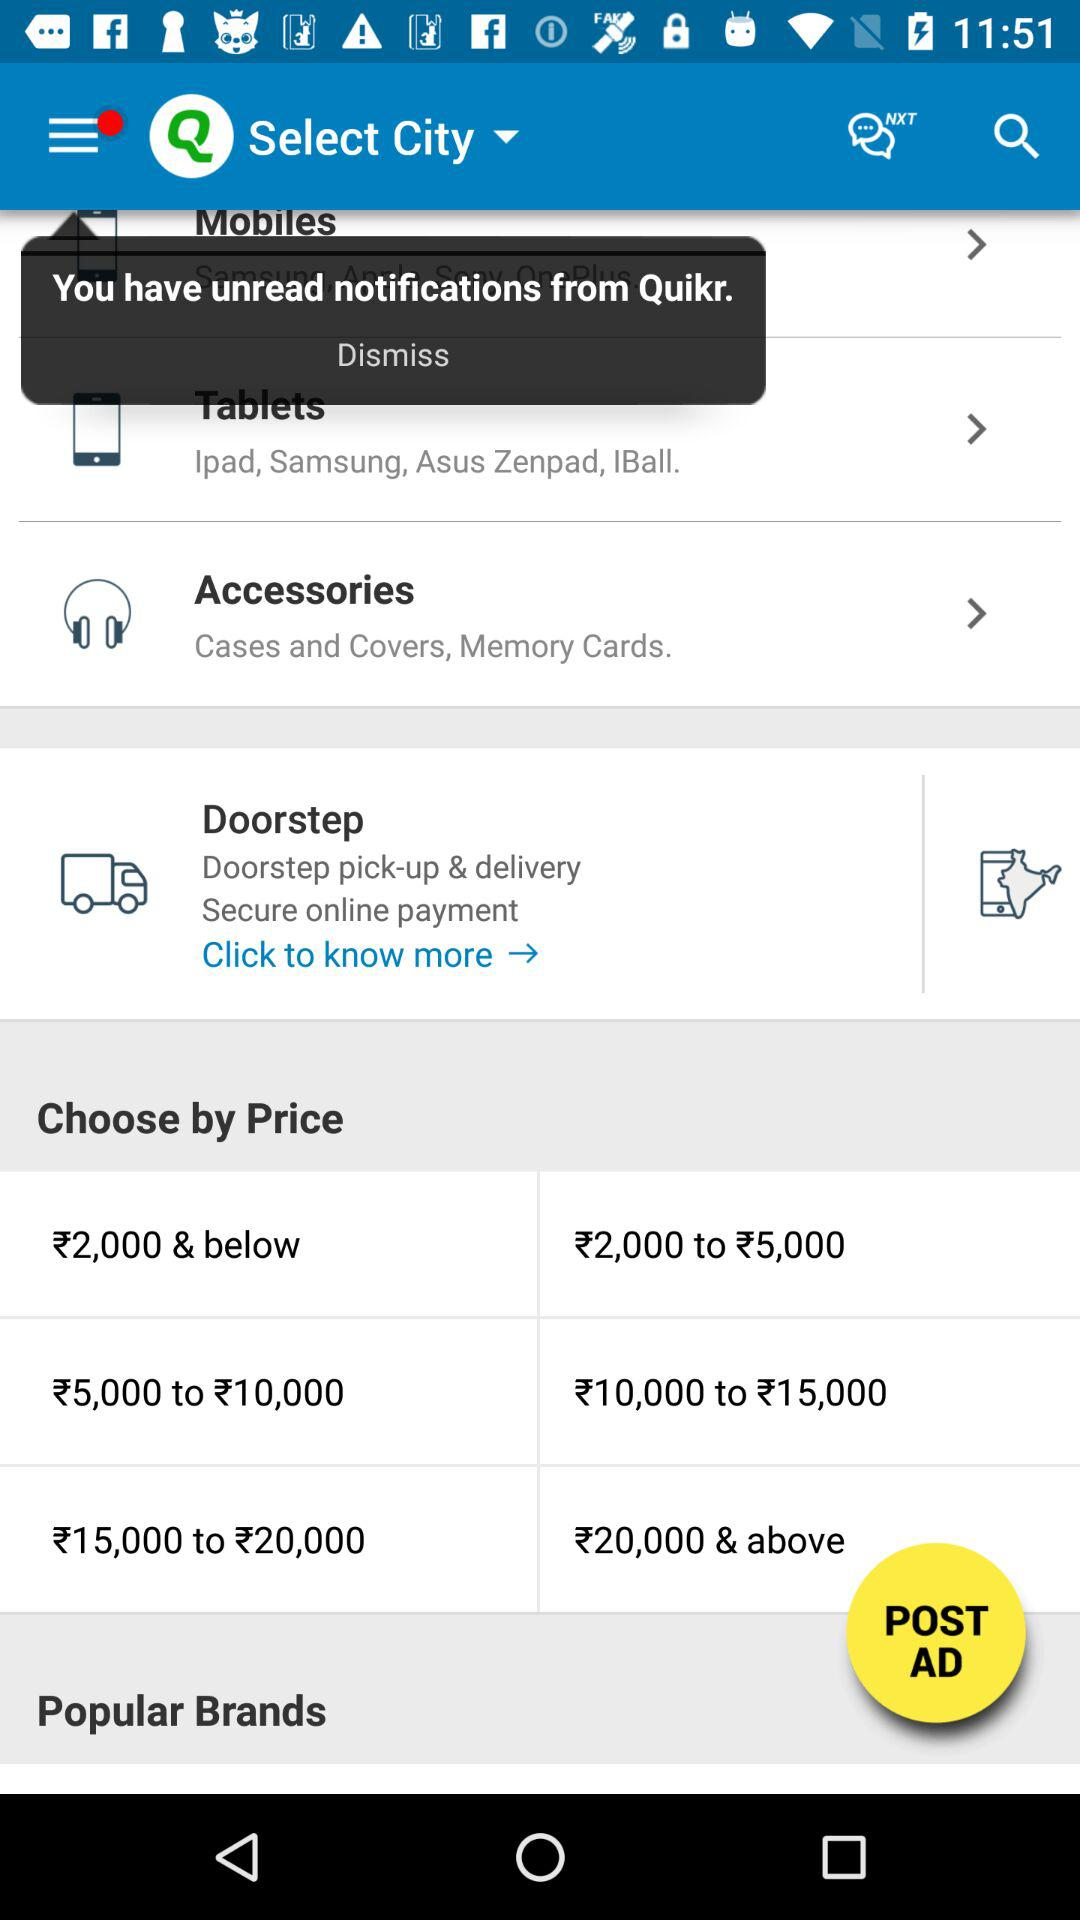What are the price ranges? The price ranges are ₹2,000 & below, ₹2,000 to ₹5,000, ₹5,000 to ₹10,000, ₹10,000 to ₹15,000, ₹15,000 to ₹20,000 and ₹20,000 & above. 